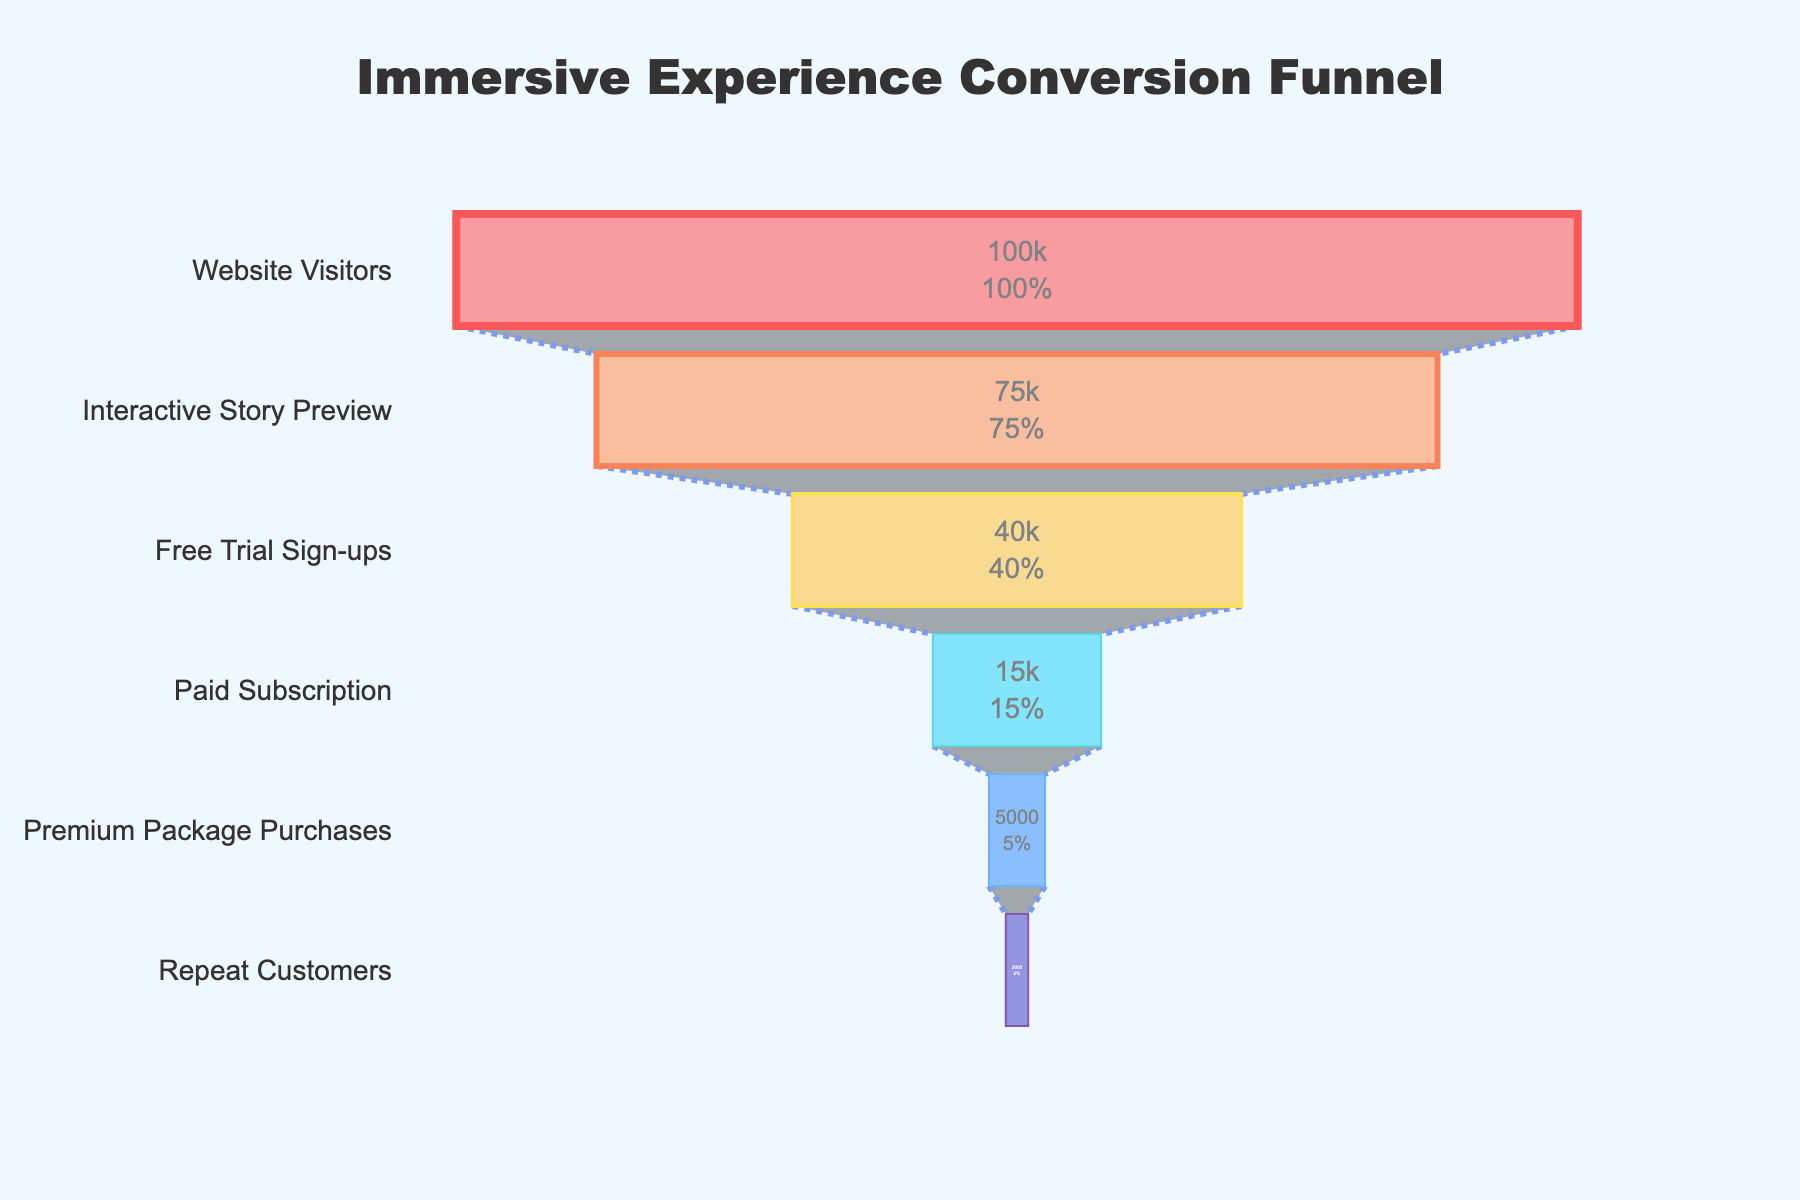What's the title of the figure? The title is prominently displayed at the top center of the figure, in large and bold font, stating the main theme or subject of the chart.
Answer: Immersive Experience Conversion Funnel How many stages are displayed in the funnel? The funnel chart has several sequential layers representing different stages of the conversion funnel. Count the number of unique labels along the y-axis.
Answer: 6 What percentage of visitors sign up for the free trial? From the "Website Visitors" stage to the "Free Trial Sign-ups" stage, the chart displays the number of visitors who signed up for the free trial. The percentage is calculated by the funnel chart's text info.
Answer: 40% How many visitors who signed up for the free trial went on to purchase the premium package? Refer to the number of visitors at the "Free Trial Sign-ups" stage and the "Premium Package Purchases" stage. Subtract the numbers to understand the changes. The number who purchased the premium package is directly shown.
Answer: 5,000 What is the conversion rate from paid subscription to repeat customers? To find the conversion rate, compare the number of visitors at the "Paid Subscription" stage to those at the "Repeat Customers" stage. Percentage calculation is shown in the funnel chart's text info.
Answer: 13.33% How many visitors do not make it past the interactive story preview stage? Subtract the visitors at the "Interactive Story Preview" stage from those at the "Website Visitors" stage.
Answer: 25,000 Is the number of free trial sign-ups more than double the number of premium package purchases? Check the visitor counts at the "Free Trial Sign-ups" and "Premium Package Purchases" stages and compare them directly. 40,000 is more than double 5,000.
Answer: Yes How many fewer repeat customers are there compared to paid subscriptions? Find the difference between the visitor numbers at the "Paid Subscription" and "Repeat Customers" stages by subtracting the smaller number from the larger one.
Answer: 13,000 Which stage has the smallest percentage drop in visitors compared to the previous stage? Check the percentage text info displayed within each stage and find the smallest percentage difference going down the funnel.
Answer: Free Trial Sign-ups to Paid Subscription What does the funnel's color gradient represent? The colors of the stages from top to bottom seem to follow a specific pattern that may indicate different stages in the conversion process. Each stage has a distinct color for easy differentiation.
Answer: Different stages in the funnel 